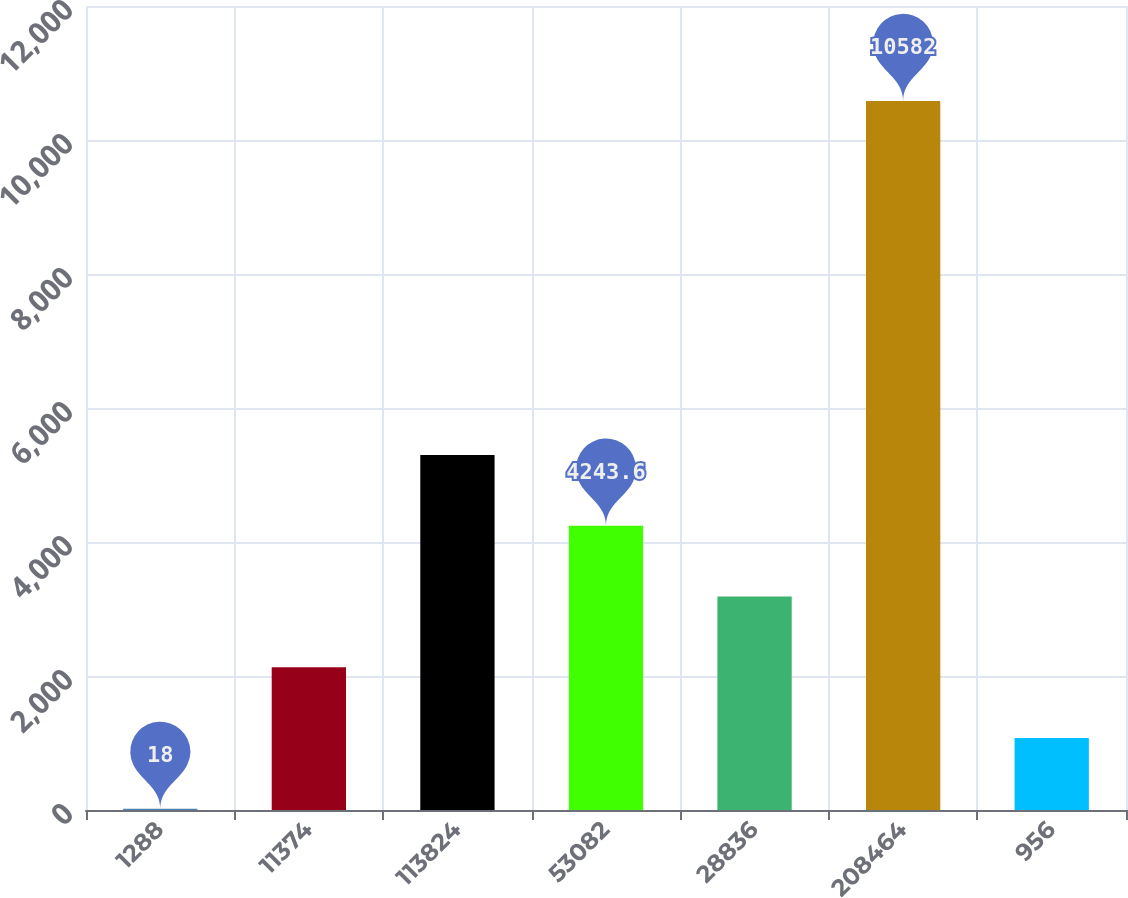Convert chart. <chart><loc_0><loc_0><loc_500><loc_500><bar_chart><fcel>1288<fcel>11374<fcel>113824<fcel>53082<fcel>28836<fcel>208464<fcel>956<nl><fcel>18<fcel>2130.8<fcel>5300<fcel>4243.6<fcel>3187.2<fcel>10582<fcel>1074.4<nl></chart> 